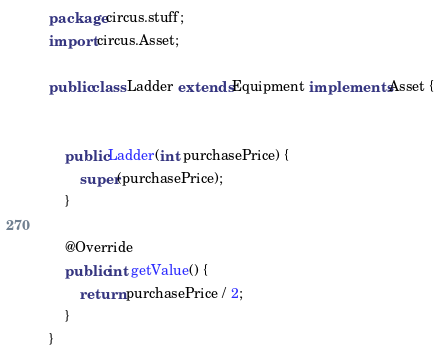<code> <loc_0><loc_0><loc_500><loc_500><_Java_>package circus.stuff;
import circus.Asset;

public class Ladder extends Equipment implements Asset {


    public Ladder(int purchasePrice) {
        super(purchasePrice);
    }

    @Override
    public int getValue() {
        return purchasePrice / 2;
    }
}
</code> 